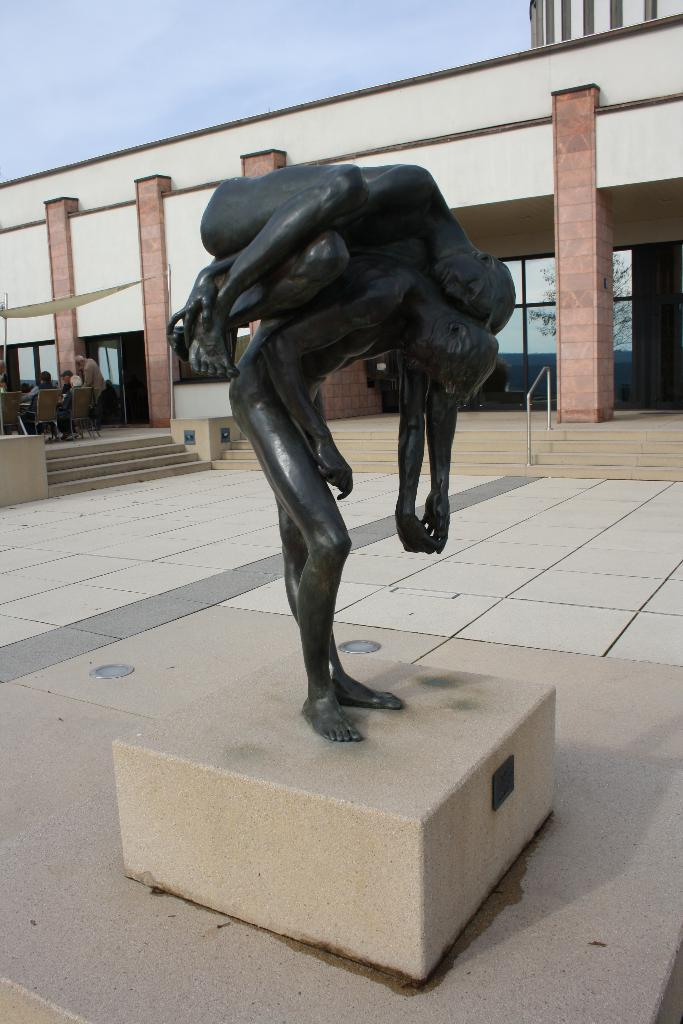What is the main subject in the image? There is a sculpture in the image. What other structures can be seen in the image? There is a building in the image. What part of the natural environment is visible in the image? The sky is visible in the image. What type of brass form can be seen in the image? There is no brass form present in the image; it features a sculpture and a building. 